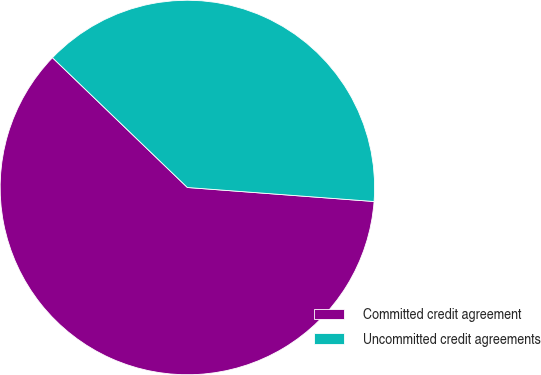<chart> <loc_0><loc_0><loc_500><loc_500><pie_chart><fcel>Committed credit agreement<fcel>Uncommitted credit agreements<nl><fcel>61.0%<fcel>39.0%<nl></chart> 